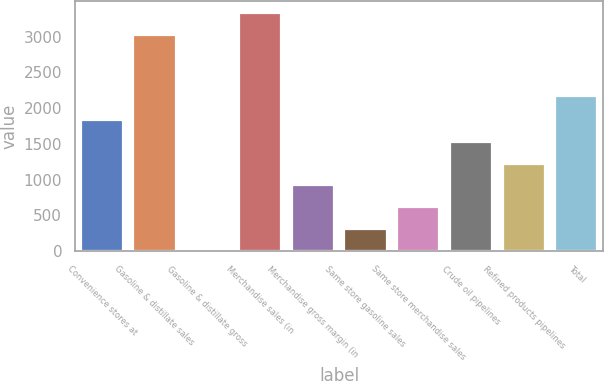Convert chart. <chart><loc_0><loc_0><loc_500><loc_500><bar_chart><fcel>Convenience stores at<fcel>Gasoline & distillate sales<fcel>Gasoline & distillate gross<fcel>Merchandise sales (in<fcel>Merchandise gross margin (in<fcel>Same store gasoline sales<fcel>Same store merchandise sales<fcel>Crude oil pipelines<fcel>Refined products pipelines<fcel>Total<nl><fcel>1834.87<fcel>3027<fcel>0.13<fcel>3332.79<fcel>917.5<fcel>305.92<fcel>611.71<fcel>1529.08<fcel>1223.29<fcel>2170<nl></chart> 